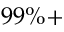Convert formula to latex. <formula><loc_0><loc_0><loc_500><loc_500>9 9 \% +</formula> 